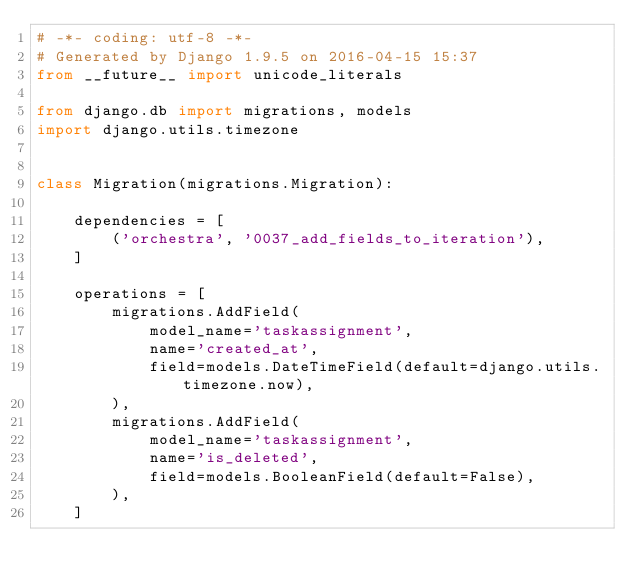<code> <loc_0><loc_0><loc_500><loc_500><_Python_># -*- coding: utf-8 -*-
# Generated by Django 1.9.5 on 2016-04-15 15:37
from __future__ import unicode_literals

from django.db import migrations, models
import django.utils.timezone


class Migration(migrations.Migration):

    dependencies = [
        ('orchestra', '0037_add_fields_to_iteration'),
    ]

    operations = [
        migrations.AddField(
            model_name='taskassignment',
            name='created_at',
            field=models.DateTimeField(default=django.utils.timezone.now),
        ),
        migrations.AddField(
            model_name='taskassignment',
            name='is_deleted',
            field=models.BooleanField(default=False),
        ),
    ]
</code> 